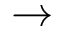<formula> <loc_0><loc_0><loc_500><loc_500>\rightarrow</formula> 